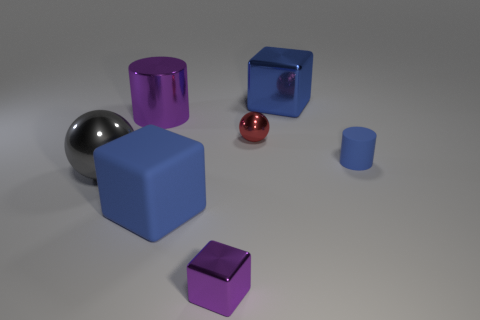There is a object that is behind the purple metallic object that is behind the purple object that is in front of the matte cube; what color is it?
Ensure brevity in your answer.  Blue. What number of objects are things left of the tiny blue cylinder or large blue cubes that are in front of the large purple cylinder?
Offer a terse response. 6. How many other objects are there of the same color as the tiny metallic block?
Offer a very short reply. 1. Does the large metal thing right of the tiny shiny ball have the same shape as the tiny matte thing?
Ensure brevity in your answer.  No. Are there fewer large rubber things that are behind the blue metal object than big yellow metal cubes?
Your response must be concise. No. Is there a blue object made of the same material as the gray ball?
Ensure brevity in your answer.  Yes. There is a gray sphere that is the same size as the shiny cylinder; what material is it?
Provide a succinct answer. Metal. Is the number of small red shiny things left of the small metal sphere less than the number of big blue objects that are behind the small purple metal object?
Give a very brief answer. Yes. What shape is the large object that is both in front of the big metallic cylinder and on the right side of the big ball?
Make the answer very short. Cube. How many other large gray objects are the same shape as the gray metallic thing?
Provide a succinct answer. 0. 